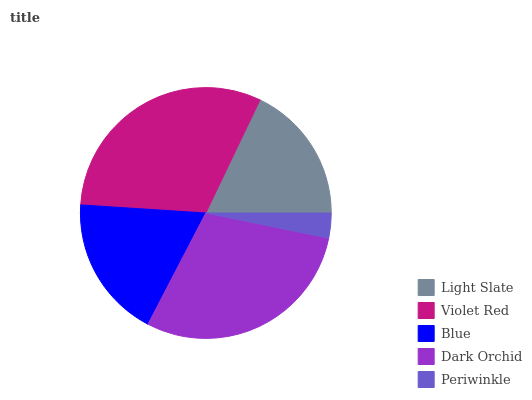Is Periwinkle the minimum?
Answer yes or no. Yes. Is Violet Red the maximum?
Answer yes or no. Yes. Is Blue the minimum?
Answer yes or no. No. Is Blue the maximum?
Answer yes or no. No. Is Violet Red greater than Blue?
Answer yes or no. Yes. Is Blue less than Violet Red?
Answer yes or no. Yes. Is Blue greater than Violet Red?
Answer yes or no. No. Is Violet Red less than Blue?
Answer yes or no. No. Is Blue the high median?
Answer yes or no. Yes. Is Blue the low median?
Answer yes or no. Yes. Is Dark Orchid the high median?
Answer yes or no. No. Is Dark Orchid the low median?
Answer yes or no. No. 